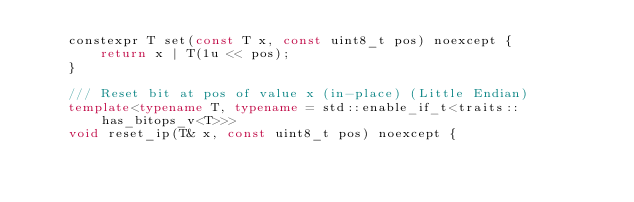<code> <loc_0><loc_0><loc_500><loc_500><_C++_>	constexpr T set(const T x, const uint8_t pos) noexcept {
		return x | T(1u << pos);
	}

	/// Reset bit at pos of value x (in-place) (Little Endian)
	template<typename T, typename = std::enable_if_t<traits::has_bitops_v<T>>>
	void reset_ip(T& x, const uint8_t pos) noexcept {</code> 